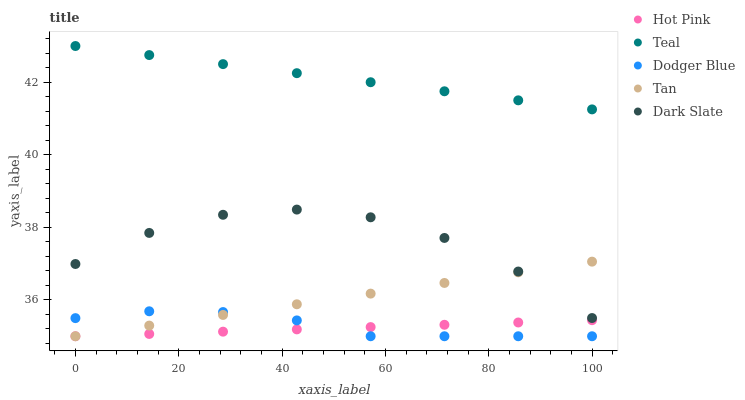Does Hot Pink have the minimum area under the curve?
Answer yes or no. Yes. Does Teal have the maximum area under the curve?
Answer yes or no. Yes. Does Tan have the minimum area under the curve?
Answer yes or no. No. Does Tan have the maximum area under the curve?
Answer yes or no. No. Is Tan the smoothest?
Answer yes or no. Yes. Is Dark Slate the roughest?
Answer yes or no. Yes. Is Hot Pink the smoothest?
Answer yes or no. No. Is Hot Pink the roughest?
Answer yes or no. No. Does Tan have the lowest value?
Answer yes or no. Yes. Does Teal have the lowest value?
Answer yes or no. No. Does Teal have the highest value?
Answer yes or no. Yes. Does Tan have the highest value?
Answer yes or no. No. Is Tan less than Teal?
Answer yes or no. Yes. Is Teal greater than Hot Pink?
Answer yes or no. Yes. Does Dodger Blue intersect Hot Pink?
Answer yes or no. Yes. Is Dodger Blue less than Hot Pink?
Answer yes or no. No. Is Dodger Blue greater than Hot Pink?
Answer yes or no. No. Does Tan intersect Teal?
Answer yes or no. No. 